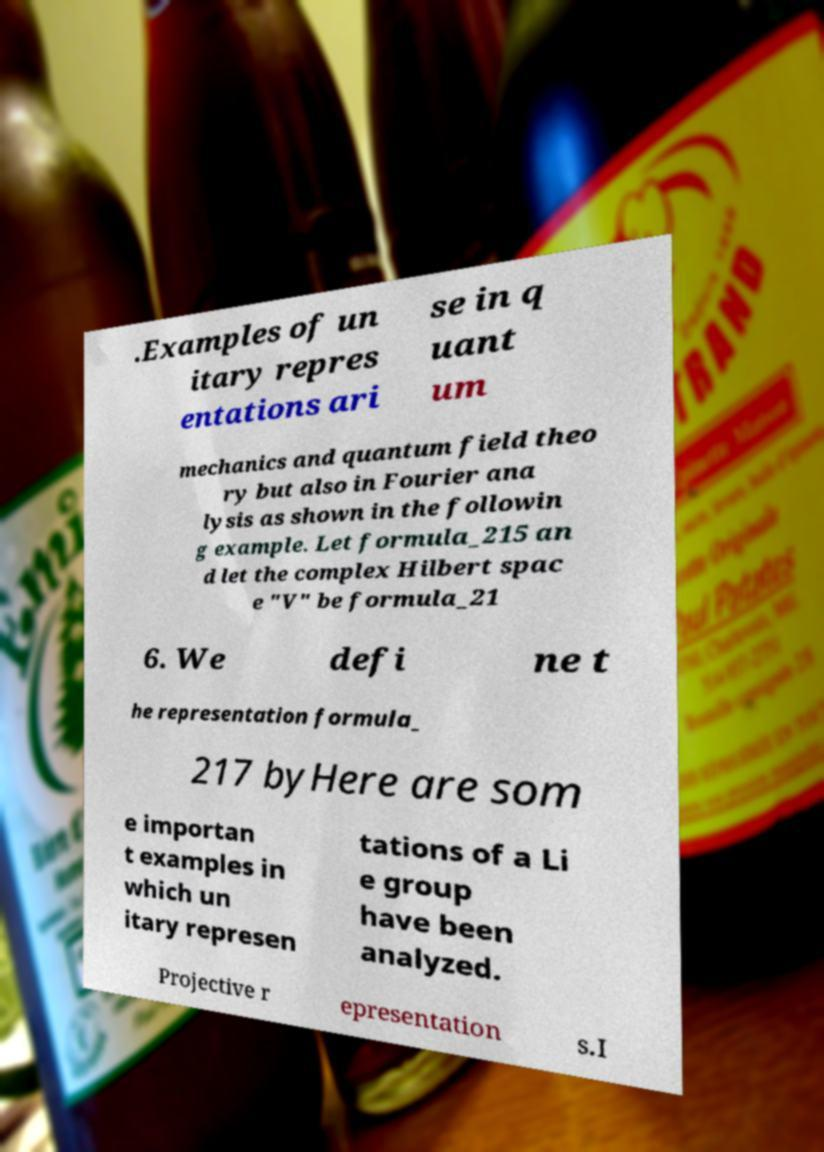Please identify and transcribe the text found in this image. .Examples of un itary repres entations ari se in q uant um mechanics and quantum field theo ry but also in Fourier ana lysis as shown in the followin g example. Let formula_215 an d let the complex Hilbert spac e "V" be formula_21 6. We defi ne t he representation formula_ 217 byHere are som e importan t examples in which un itary represen tations of a Li e group have been analyzed. Projective r epresentation s.I 